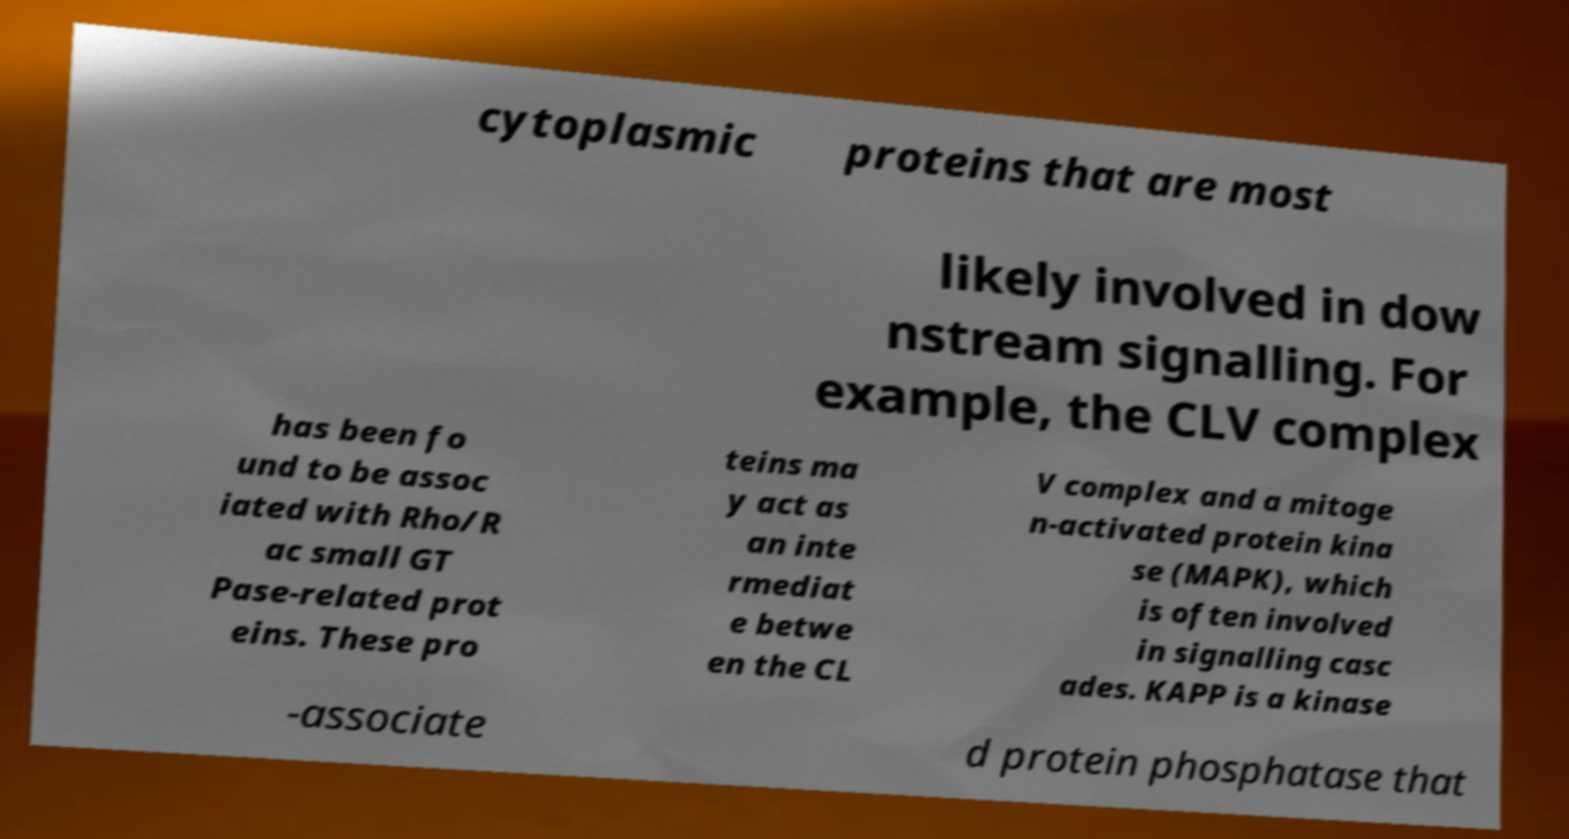Can you accurately transcribe the text from the provided image for me? cytoplasmic proteins that are most likely involved in dow nstream signalling. For example, the CLV complex has been fo und to be assoc iated with Rho/R ac small GT Pase-related prot eins. These pro teins ma y act as an inte rmediat e betwe en the CL V complex and a mitoge n-activated protein kina se (MAPK), which is often involved in signalling casc ades. KAPP is a kinase -associate d protein phosphatase that 